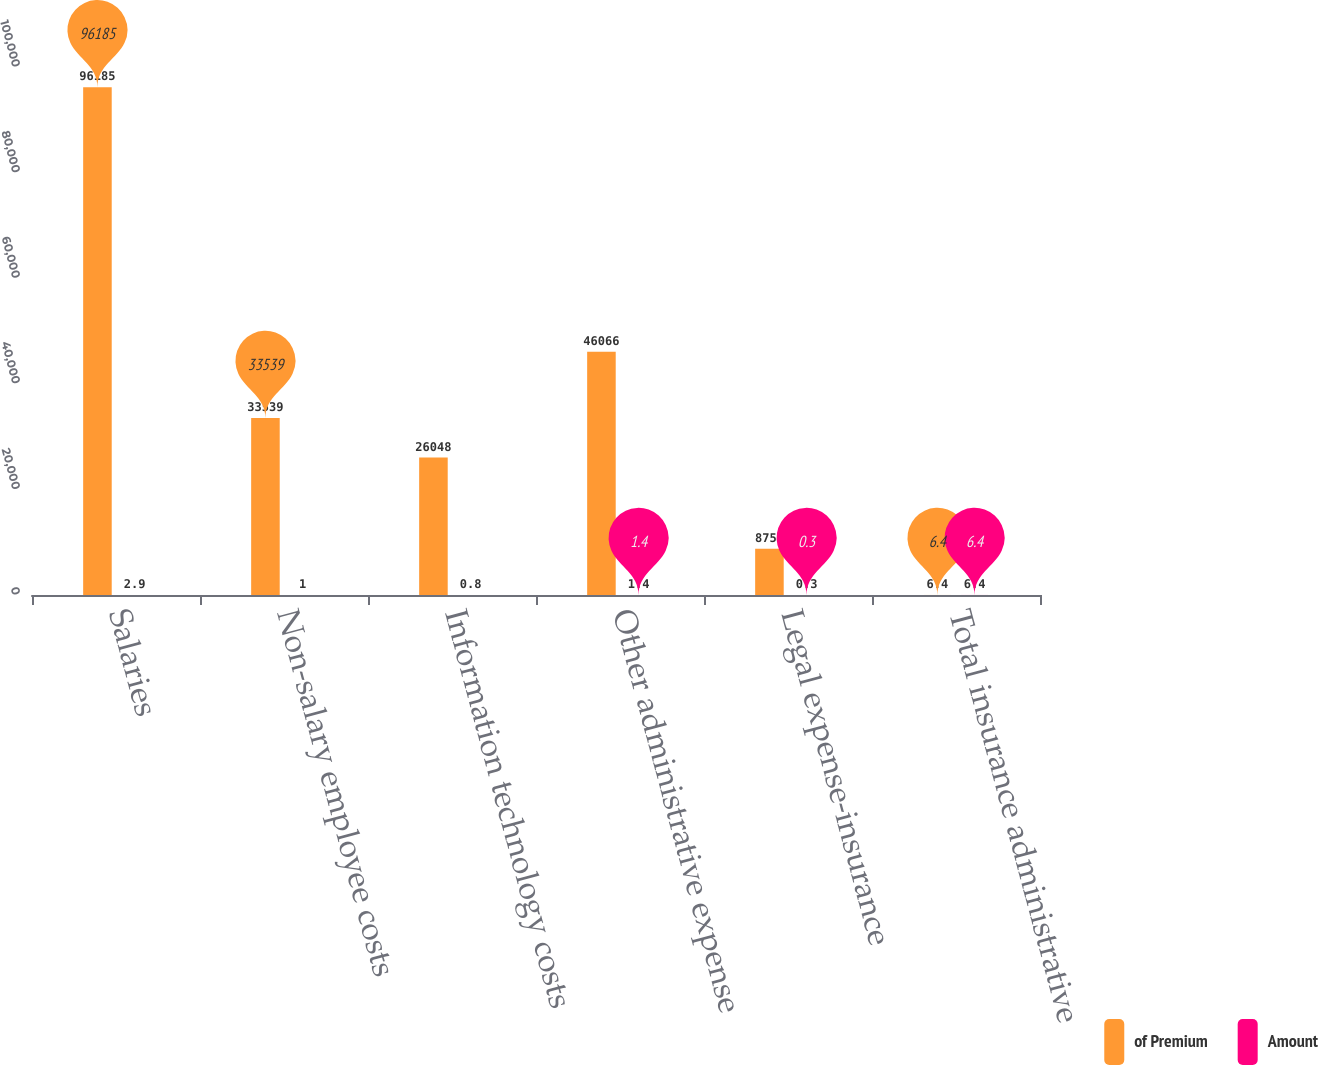Convert chart. <chart><loc_0><loc_0><loc_500><loc_500><stacked_bar_chart><ecel><fcel>Salaries<fcel>Non-salary employee costs<fcel>Information technology costs<fcel>Other administrative expense<fcel>Legal expense-insurance<fcel>Total insurance administrative<nl><fcel>of Premium<fcel>96185<fcel>33539<fcel>26048<fcel>46066<fcel>8752<fcel>6.4<nl><fcel>Amount<fcel>2.9<fcel>1<fcel>0.8<fcel>1.4<fcel>0.3<fcel>6.4<nl></chart> 